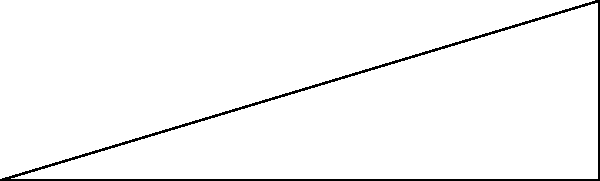As part of a new security initiative, a police watchtower is being constructed near the precinct. From a point A on the ground, the angle of elevation to the top of the watchtower is 30°. If the distance from point A to the base of the watchtower is 50 meters, calculate the height of the watchtower to the nearest meter. Let's approach this step-by-step:

1) We can model this situation as a right-angled triangle, where:
   - The base of the triangle is the distance from point A to the base of the watchtower (50 m)
   - The height of the triangle is the height of the watchtower (what we're trying to find)
   - The angle of elevation is 30°

2) In this right-angled triangle, we know:
   - The adjacent side (base) = 50 m
   - The angle = 30°
   - We need to find the opposite side (height)

3) This scenario calls for the use of the tangent trigonometric function:

   $\tan \theta = \frac{\text{opposite}}{\text{adjacent}}$

4) Substituting our known values:

   $\tan 30° = \frac{\text{height}}{50}$

5) We can rearrange this to solve for height:

   $\text{height} = 50 \times \tan 30°$

6) Now, let's calculate:
   $\tan 30° \approx 0.5773$
   
   $\text{height} = 50 \times 0.5773 \approx 28.8650$ meters

7) Rounding to the nearest meter:

   $\text{height} \approx 29$ meters
Answer: 29 meters 